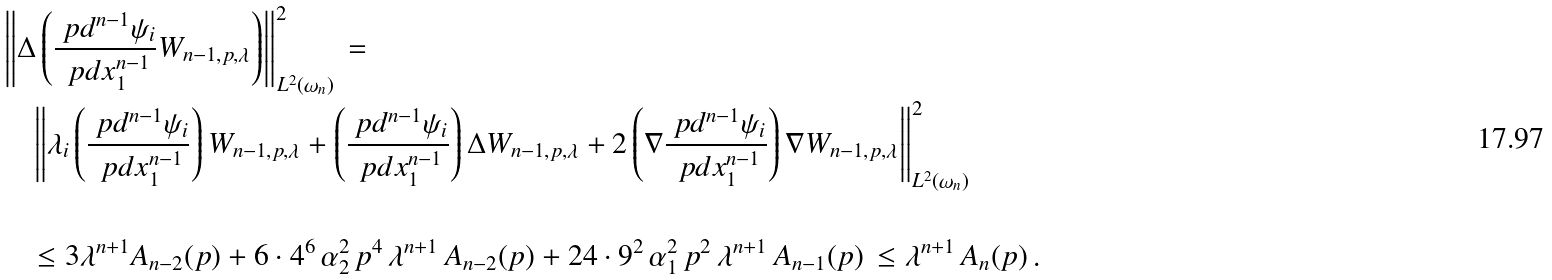Convert formula to latex. <formula><loc_0><loc_0><loc_500><loc_500>& \left \| \Delta \left ( \frac { \ p d ^ { n - 1 } \psi _ { i } } { \ p d x _ { 1 } ^ { n - 1 } } W _ { n - 1 , p , \lambda } \right ) \right \| ^ { 2 } _ { L ^ { 2 } ( \omega _ { n } ) } \, = \\ & \quad \left \| \lambda _ { i } \left ( \frac { \ p d ^ { n - 1 } \psi _ { i } } { \ p d x _ { 1 } ^ { n - 1 } } \right ) W _ { n - 1 , p , \lambda } + \left ( \frac { \ p d ^ { n - 1 } \psi _ { i } } { \ p d x _ { 1 } ^ { n - 1 } } \right ) \Delta W _ { n - 1 , p , \lambda } + 2 \left ( \nabla \frac { \ p d ^ { n - 1 } \psi _ { i } } { \ p d x _ { 1 } ^ { n - 1 } } \right ) \nabla W _ { n - 1 , p , \lambda } \right \| ^ { 2 } _ { L ^ { 2 } ( \omega _ { n } ) } \\ & \\ & \quad \leq 3 \lambda ^ { n + 1 } A _ { n - 2 } ( p ) + 6 \cdot 4 ^ { 6 } \, \alpha _ { 2 } ^ { 2 } \, p ^ { 4 } \, \lambda ^ { n + 1 } \, A _ { n - 2 } ( p ) + 2 4 \cdot 9 ^ { 2 } \, \alpha _ { 1 } ^ { 2 } \, p ^ { 2 } \, \lambda ^ { n + 1 } \, A _ { n - 1 } ( p ) \, \leq \lambda ^ { n + 1 } \, A _ { n } ( p ) \, .</formula> 